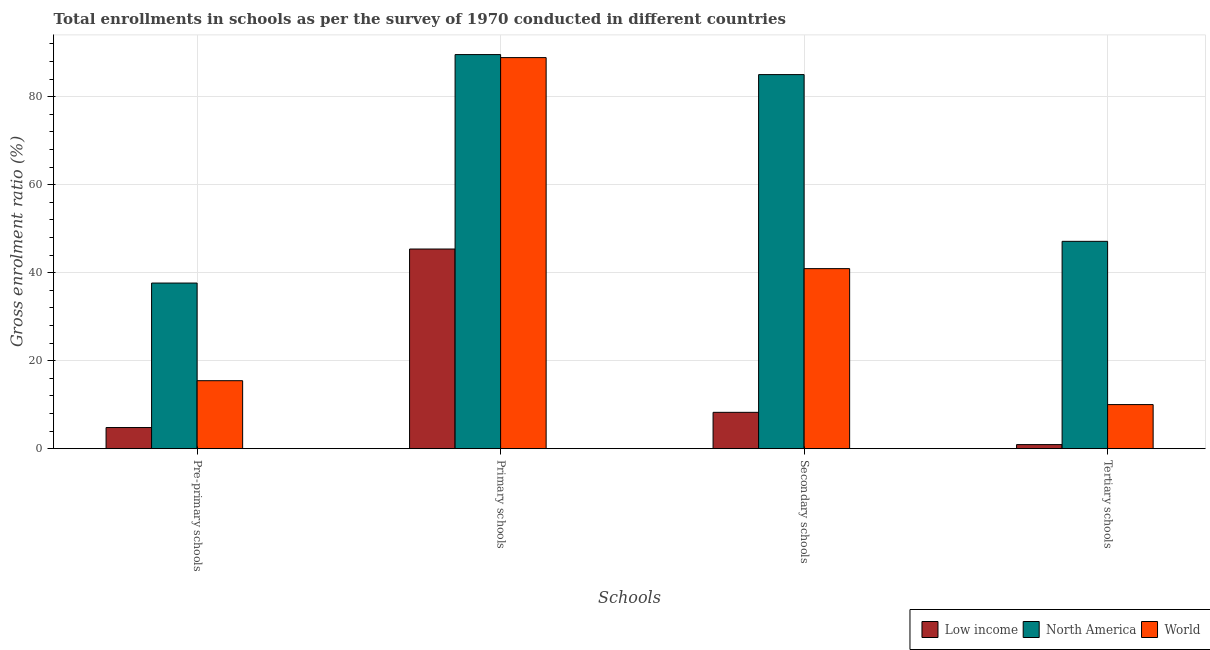How many groups of bars are there?
Your answer should be very brief. 4. Are the number of bars on each tick of the X-axis equal?
Your answer should be very brief. Yes. What is the label of the 2nd group of bars from the left?
Give a very brief answer. Primary schools. What is the gross enrolment ratio in primary schools in Low income?
Ensure brevity in your answer.  45.37. Across all countries, what is the maximum gross enrolment ratio in tertiary schools?
Provide a succinct answer. 47.11. Across all countries, what is the minimum gross enrolment ratio in tertiary schools?
Give a very brief answer. 0.93. What is the total gross enrolment ratio in secondary schools in the graph?
Provide a short and direct response. 134.18. What is the difference between the gross enrolment ratio in tertiary schools in North America and that in Low income?
Provide a short and direct response. 46.19. What is the difference between the gross enrolment ratio in pre-primary schools in World and the gross enrolment ratio in secondary schools in North America?
Make the answer very short. -69.56. What is the average gross enrolment ratio in tertiary schools per country?
Offer a terse response. 19.35. What is the difference between the gross enrolment ratio in secondary schools and gross enrolment ratio in tertiary schools in Low income?
Make the answer very short. 7.33. What is the ratio of the gross enrolment ratio in secondary schools in North America to that in Low income?
Keep it short and to the point. 10.29. Is the difference between the gross enrolment ratio in pre-primary schools in North America and Low income greater than the difference between the gross enrolment ratio in tertiary schools in North America and Low income?
Ensure brevity in your answer.  No. What is the difference between the highest and the second highest gross enrolment ratio in secondary schools?
Your answer should be compact. 44.09. What is the difference between the highest and the lowest gross enrolment ratio in secondary schools?
Your answer should be compact. 76.75. In how many countries, is the gross enrolment ratio in primary schools greater than the average gross enrolment ratio in primary schools taken over all countries?
Make the answer very short. 2. Is the sum of the gross enrolment ratio in pre-primary schools in World and North America greater than the maximum gross enrolment ratio in tertiary schools across all countries?
Ensure brevity in your answer.  Yes. Is it the case that in every country, the sum of the gross enrolment ratio in tertiary schools and gross enrolment ratio in pre-primary schools is greater than the sum of gross enrolment ratio in secondary schools and gross enrolment ratio in primary schools?
Make the answer very short. No. What does the 3rd bar from the right in Primary schools represents?
Offer a very short reply. Low income. Is it the case that in every country, the sum of the gross enrolment ratio in pre-primary schools and gross enrolment ratio in primary schools is greater than the gross enrolment ratio in secondary schools?
Make the answer very short. Yes. How many bars are there?
Offer a very short reply. 12. How many countries are there in the graph?
Ensure brevity in your answer.  3. What is the difference between two consecutive major ticks on the Y-axis?
Your answer should be very brief. 20. Are the values on the major ticks of Y-axis written in scientific E-notation?
Provide a succinct answer. No. Does the graph contain grids?
Provide a short and direct response. Yes. Where does the legend appear in the graph?
Give a very brief answer. Bottom right. How many legend labels are there?
Make the answer very short. 3. What is the title of the graph?
Your answer should be compact. Total enrollments in schools as per the survey of 1970 conducted in different countries. What is the label or title of the X-axis?
Ensure brevity in your answer.  Schools. What is the label or title of the Y-axis?
Offer a very short reply. Gross enrolment ratio (%). What is the Gross enrolment ratio (%) of Low income in Pre-primary schools?
Provide a succinct answer. 4.8. What is the Gross enrolment ratio (%) of North America in Pre-primary schools?
Give a very brief answer. 37.64. What is the Gross enrolment ratio (%) of World in Pre-primary schools?
Offer a very short reply. 15.45. What is the Gross enrolment ratio (%) in Low income in Primary schools?
Give a very brief answer. 45.37. What is the Gross enrolment ratio (%) in North America in Primary schools?
Your answer should be very brief. 89.56. What is the Gross enrolment ratio (%) of World in Primary schools?
Offer a terse response. 88.87. What is the Gross enrolment ratio (%) of Low income in Secondary schools?
Keep it short and to the point. 8.26. What is the Gross enrolment ratio (%) in North America in Secondary schools?
Your answer should be very brief. 85. What is the Gross enrolment ratio (%) of World in Secondary schools?
Provide a succinct answer. 40.91. What is the Gross enrolment ratio (%) in Low income in Tertiary schools?
Keep it short and to the point. 0.93. What is the Gross enrolment ratio (%) of North America in Tertiary schools?
Your response must be concise. 47.11. What is the Gross enrolment ratio (%) of World in Tertiary schools?
Provide a succinct answer. 10.02. Across all Schools, what is the maximum Gross enrolment ratio (%) in Low income?
Give a very brief answer. 45.37. Across all Schools, what is the maximum Gross enrolment ratio (%) in North America?
Your response must be concise. 89.56. Across all Schools, what is the maximum Gross enrolment ratio (%) in World?
Give a very brief answer. 88.87. Across all Schools, what is the minimum Gross enrolment ratio (%) of Low income?
Your answer should be very brief. 0.93. Across all Schools, what is the minimum Gross enrolment ratio (%) in North America?
Offer a terse response. 37.64. Across all Schools, what is the minimum Gross enrolment ratio (%) of World?
Ensure brevity in your answer.  10.02. What is the total Gross enrolment ratio (%) of Low income in the graph?
Your response must be concise. 59.36. What is the total Gross enrolment ratio (%) in North America in the graph?
Your answer should be very brief. 259.31. What is the total Gross enrolment ratio (%) in World in the graph?
Your answer should be compact. 155.25. What is the difference between the Gross enrolment ratio (%) of Low income in Pre-primary schools and that in Primary schools?
Provide a succinct answer. -40.57. What is the difference between the Gross enrolment ratio (%) in North America in Pre-primary schools and that in Primary schools?
Your response must be concise. -51.92. What is the difference between the Gross enrolment ratio (%) in World in Pre-primary schools and that in Primary schools?
Offer a terse response. -73.42. What is the difference between the Gross enrolment ratio (%) in Low income in Pre-primary schools and that in Secondary schools?
Provide a short and direct response. -3.46. What is the difference between the Gross enrolment ratio (%) in North America in Pre-primary schools and that in Secondary schools?
Provide a succinct answer. -47.37. What is the difference between the Gross enrolment ratio (%) in World in Pre-primary schools and that in Secondary schools?
Your answer should be compact. -25.47. What is the difference between the Gross enrolment ratio (%) of Low income in Pre-primary schools and that in Tertiary schools?
Offer a very short reply. 3.88. What is the difference between the Gross enrolment ratio (%) in North America in Pre-primary schools and that in Tertiary schools?
Make the answer very short. -9.48. What is the difference between the Gross enrolment ratio (%) of World in Pre-primary schools and that in Tertiary schools?
Give a very brief answer. 5.43. What is the difference between the Gross enrolment ratio (%) of Low income in Primary schools and that in Secondary schools?
Your answer should be compact. 37.11. What is the difference between the Gross enrolment ratio (%) of North America in Primary schools and that in Secondary schools?
Keep it short and to the point. 4.55. What is the difference between the Gross enrolment ratio (%) in World in Primary schools and that in Secondary schools?
Provide a short and direct response. 47.95. What is the difference between the Gross enrolment ratio (%) of Low income in Primary schools and that in Tertiary schools?
Make the answer very short. 44.44. What is the difference between the Gross enrolment ratio (%) in North America in Primary schools and that in Tertiary schools?
Provide a succinct answer. 42.44. What is the difference between the Gross enrolment ratio (%) of World in Primary schools and that in Tertiary schools?
Keep it short and to the point. 78.85. What is the difference between the Gross enrolment ratio (%) in Low income in Secondary schools and that in Tertiary schools?
Your answer should be compact. 7.33. What is the difference between the Gross enrolment ratio (%) of North America in Secondary schools and that in Tertiary schools?
Ensure brevity in your answer.  37.89. What is the difference between the Gross enrolment ratio (%) of World in Secondary schools and that in Tertiary schools?
Give a very brief answer. 30.9. What is the difference between the Gross enrolment ratio (%) in Low income in Pre-primary schools and the Gross enrolment ratio (%) in North America in Primary schools?
Make the answer very short. -84.75. What is the difference between the Gross enrolment ratio (%) of Low income in Pre-primary schools and the Gross enrolment ratio (%) of World in Primary schools?
Offer a very short reply. -84.07. What is the difference between the Gross enrolment ratio (%) of North America in Pre-primary schools and the Gross enrolment ratio (%) of World in Primary schools?
Provide a succinct answer. -51.23. What is the difference between the Gross enrolment ratio (%) in Low income in Pre-primary schools and the Gross enrolment ratio (%) in North America in Secondary schools?
Give a very brief answer. -80.2. What is the difference between the Gross enrolment ratio (%) of Low income in Pre-primary schools and the Gross enrolment ratio (%) of World in Secondary schools?
Provide a short and direct response. -36.11. What is the difference between the Gross enrolment ratio (%) of North America in Pre-primary schools and the Gross enrolment ratio (%) of World in Secondary schools?
Your response must be concise. -3.28. What is the difference between the Gross enrolment ratio (%) in Low income in Pre-primary schools and the Gross enrolment ratio (%) in North America in Tertiary schools?
Make the answer very short. -42.31. What is the difference between the Gross enrolment ratio (%) in Low income in Pre-primary schools and the Gross enrolment ratio (%) in World in Tertiary schools?
Your response must be concise. -5.22. What is the difference between the Gross enrolment ratio (%) in North America in Pre-primary schools and the Gross enrolment ratio (%) in World in Tertiary schools?
Keep it short and to the point. 27.62. What is the difference between the Gross enrolment ratio (%) of Low income in Primary schools and the Gross enrolment ratio (%) of North America in Secondary schools?
Your response must be concise. -39.63. What is the difference between the Gross enrolment ratio (%) in Low income in Primary schools and the Gross enrolment ratio (%) in World in Secondary schools?
Offer a terse response. 4.46. What is the difference between the Gross enrolment ratio (%) of North America in Primary schools and the Gross enrolment ratio (%) of World in Secondary schools?
Make the answer very short. 48.64. What is the difference between the Gross enrolment ratio (%) of Low income in Primary schools and the Gross enrolment ratio (%) of North America in Tertiary schools?
Keep it short and to the point. -1.74. What is the difference between the Gross enrolment ratio (%) of Low income in Primary schools and the Gross enrolment ratio (%) of World in Tertiary schools?
Offer a terse response. 35.35. What is the difference between the Gross enrolment ratio (%) of North America in Primary schools and the Gross enrolment ratio (%) of World in Tertiary schools?
Provide a succinct answer. 79.54. What is the difference between the Gross enrolment ratio (%) of Low income in Secondary schools and the Gross enrolment ratio (%) of North America in Tertiary schools?
Ensure brevity in your answer.  -38.86. What is the difference between the Gross enrolment ratio (%) of Low income in Secondary schools and the Gross enrolment ratio (%) of World in Tertiary schools?
Your answer should be very brief. -1.76. What is the difference between the Gross enrolment ratio (%) of North America in Secondary schools and the Gross enrolment ratio (%) of World in Tertiary schools?
Provide a succinct answer. 74.99. What is the average Gross enrolment ratio (%) in Low income per Schools?
Keep it short and to the point. 14.84. What is the average Gross enrolment ratio (%) in North America per Schools?
Your response must be concise. 64.83. What is the average Gross enrolment ratio (%) in World per Schools?
Your answer should be very brief. 38.81. What is the difference between the Gross enrolment ratio (%) in Low income and Gross enrolment ratio (%) in North America in Pre-primary schools?
Offer a terse response. -32.83. What is the difference between the Gross enrolment ratio (%) of Low income and Gross enrolment ratio (%) of World in Pre-primary schools?
Your answer should be compact. -10.65. What is the difference between the Gross enrolment ratio (%) of North America and Gross enrolment ratio (%) of World in Pre-primary schools?
Your answer should be compact. 22.19. What is the difference between the Gross enrolment ratio (%) in Low income and Gross enrolment ratio (%) in North America in Primary schools?
Provide a succinct answer. -44.18. What is the difference between the Gross enrolment ratio (%) of Low income and Gross enrolment ratio (%) of World in Primary schools?
Provide a short and direct response. -43.5. What is the difference between the Gross enrolment ratio (%) of North America and Gross enrolment ratio (%) of World in Primary schools?
Ensure brevity in your answer.  0.69. What is the difference between the Gross enrolment ratio (%) in Low income and Gross enrolment ratio (%) in North America in Secondary schools?
Your answer should be compact. -76.75. What is the difference between the Gross enrolment ratio (%) in Low income and Gross enrolment ratio (%) in World in Secondary schools?
Your response must be concise. -32.66. What is the difference between the Gross enrolment ratio (%) of North America and Gross enrolment ratio (%) of World in Secondary schools?
Your answer should be compact. 44.09. What is the difference between the Gross enrolment ratio (%) in Low income and Gross enrolment ratio (%) in North America in Tertiary schools?
Make the answer very short. -46.19. What is the difference between the Gross enrolment ratio (%) of Low income and Gross enrolment ratio (%) of World in Tertiary schools?
Provide a short and direct response. -9.09. What is the difference between the Gross enrolment ratio (%) of North America and Gross enrolment ratio (%) of World in Tertiary schools?
Give a very brief answer. 37.1. What is the ratio of the Gross enrolment ratio (%) of Low income in Pre-primary schools to that in Primary schools?
Your answer should be very brief. 0.11. What is the ratio of the Gross enrolment ratio (%) of North America in Pre-primary schools to that in Primary schools?
Offer a very short reply. 0.42. What is the ratio of the Gross enrolment ratio (%) in World in Pre-primary schools to that in Primary schools?
Your response must be concise. 0.17. What is the ratio of the Gross enrolment ratio (%) of Low income in Pre-primary schools to that in Secondary schools?
Provide a succinct answer. 0.58. What is the ratio of the Gross enrolment ratio (%) of North America in Pre-primary schools to that in Secondary schools?
Your answer should be very brief. 0.44. What is the ratio of the Gross enrolment ratio (%) of World in Pre-primary schools to that in Secondary schools?
Give a very brief answer. 0.38. What is the ratio of the Gross enrolment ratio (%) of Low income in Pre-primary schools to that in Tertiary schools?
Make the answer very short. 5.18. What is the ratio of the Gross enrolment ratio (%) of North America in Pre-primary schools to that in Tertiary schools?
Make the answer very short. 0.8. What is the ratio of the Gross enrolment ratio (%) of World in Pre-primary schools to that in Tertiary schools?
Give a very brief answer. 1.54. What is the ratio of the Gross enrolment ratio (%) in Low income in Primary schools to that in Secondary schools?
Your answer should be compact. 5.49. What is the ratio of the Gross enrolment ratio (%) of North America in Primary schools to that in Secondary schools?
Your answer should be very brief. 1.05. What is the ratio of the Gross enrolment ratio (%) of World in Primary schools to that in Secondary schools?
Your response must be concise. 2.17. What is the ratio of the Gross enrolment ratio (%) of Low income in Primary schools to that in Tertiary schools?
Provide a succinct answer. 48.95. What is the ratio of the Gross enrolment ratio (%) in North America in Primary schools to that in Tertiary schools?
Your answer should be very brief. 1.9. What is the ratio of the Gross enrolment ratio (%) of World in Primary schools to that in Tertiary schools?
Give a very brief answer. 8.87. What is the ratio of the Gross enrolment ratio (%) of Low income in Secondary schools to that in Tertiary schools?
Your answer should be very brief. 8.91. What is the ratio of the Gross enrolment ratio (%) in North America in Secondary schools to that in Tertiary schools?
Your answer should be compact. 1.8. What is the ratio of the Gross enrolment ratio (%) in World in Secondary schools to that in Tertiary schools?
Offer a very short reply. 4.08. What is the difference between the highest and the second highest Gross enrolment ratio (%) in Low income?
Your answer should be very brief. 37.11. What is the difference between the highest and the second highest Gross enrolment ratio (%) of North America?
Your answer should be very brief. 4.55. What is the difference between the highest and the second highest Gross enrolment ratio (%) in World?
Ensure brevity in your answer.  47.95. What is the difference between the highest and the lowest Gross enrolment ratio (%) of Low income?
Your answer should be compact. 44.44. What is the difference between the highest and the lowest Gross enrolment ratio (%) in North America?
Keep it short and to the point. 51.92. What is the difference between the highest and the lowest Gross enrolment ratio (%) of World?
Your answer should be very brief. 78.85. 